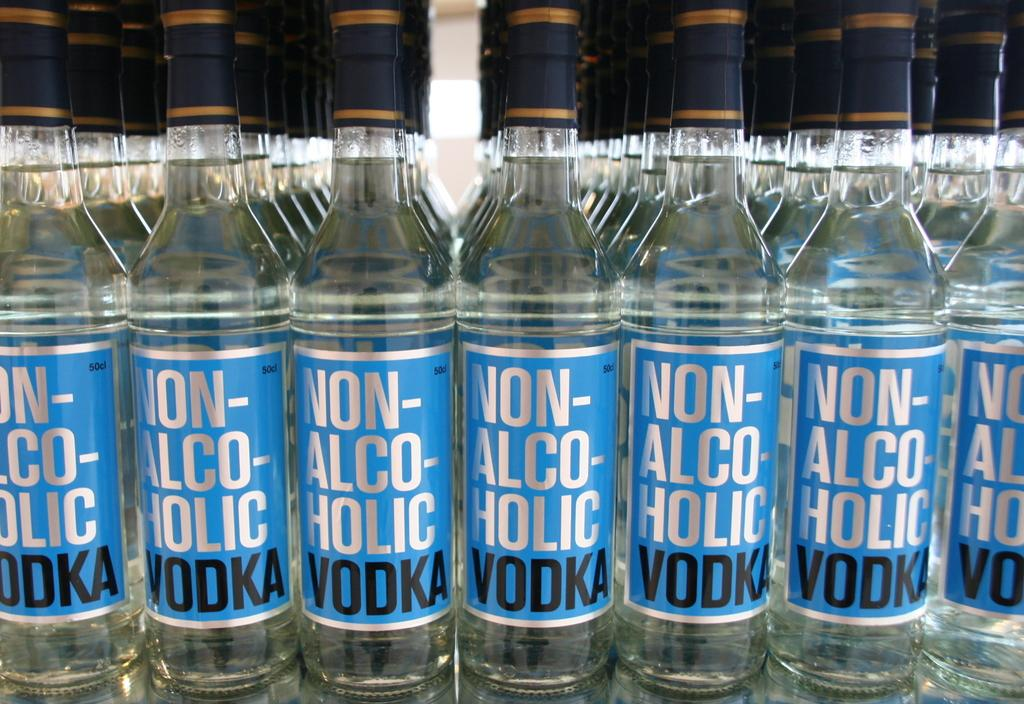<image>
Provide a brief description of the given image. A row of Non-Alcholholic Vodka sits on display 